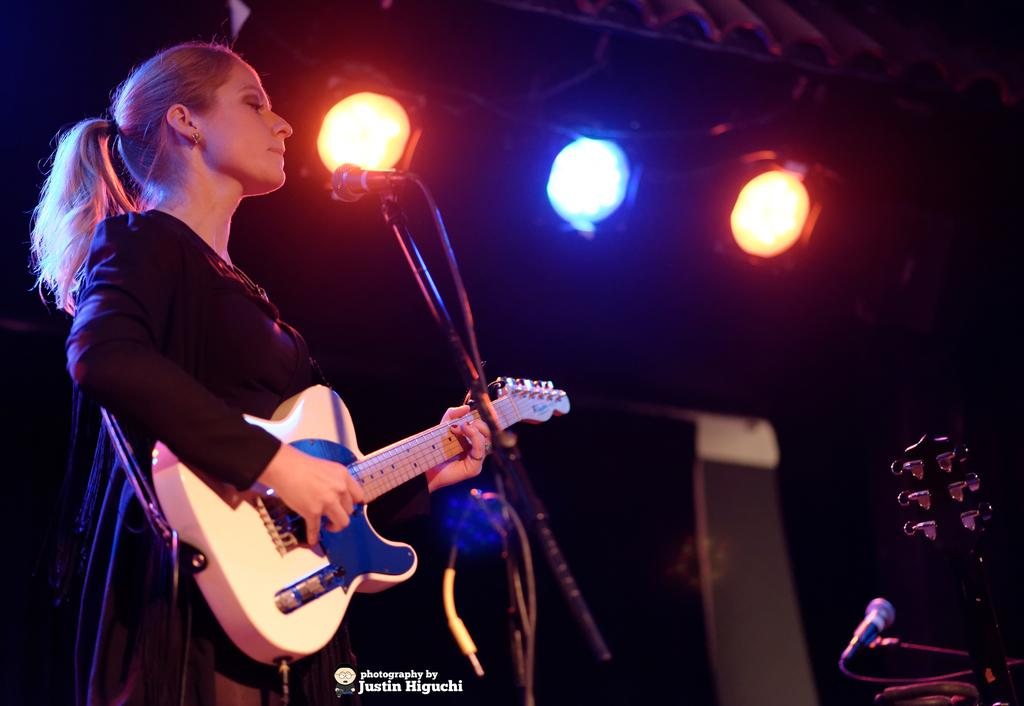What is the main subject of the image? The main subject of the image is a lady person. What is the lady person wearing? The lady person is wearing a black dress. What activity is the lady person engaged in? The lady person is playing a guitar. What object is in front of the lady person? There is a microphone in front of the lady person. What can be seen at the top of the image? There are lights visible at the top of the image. What type of metal is the worm made of in the image? There is no worm present in the image, and therefore no such metal can be identified. 